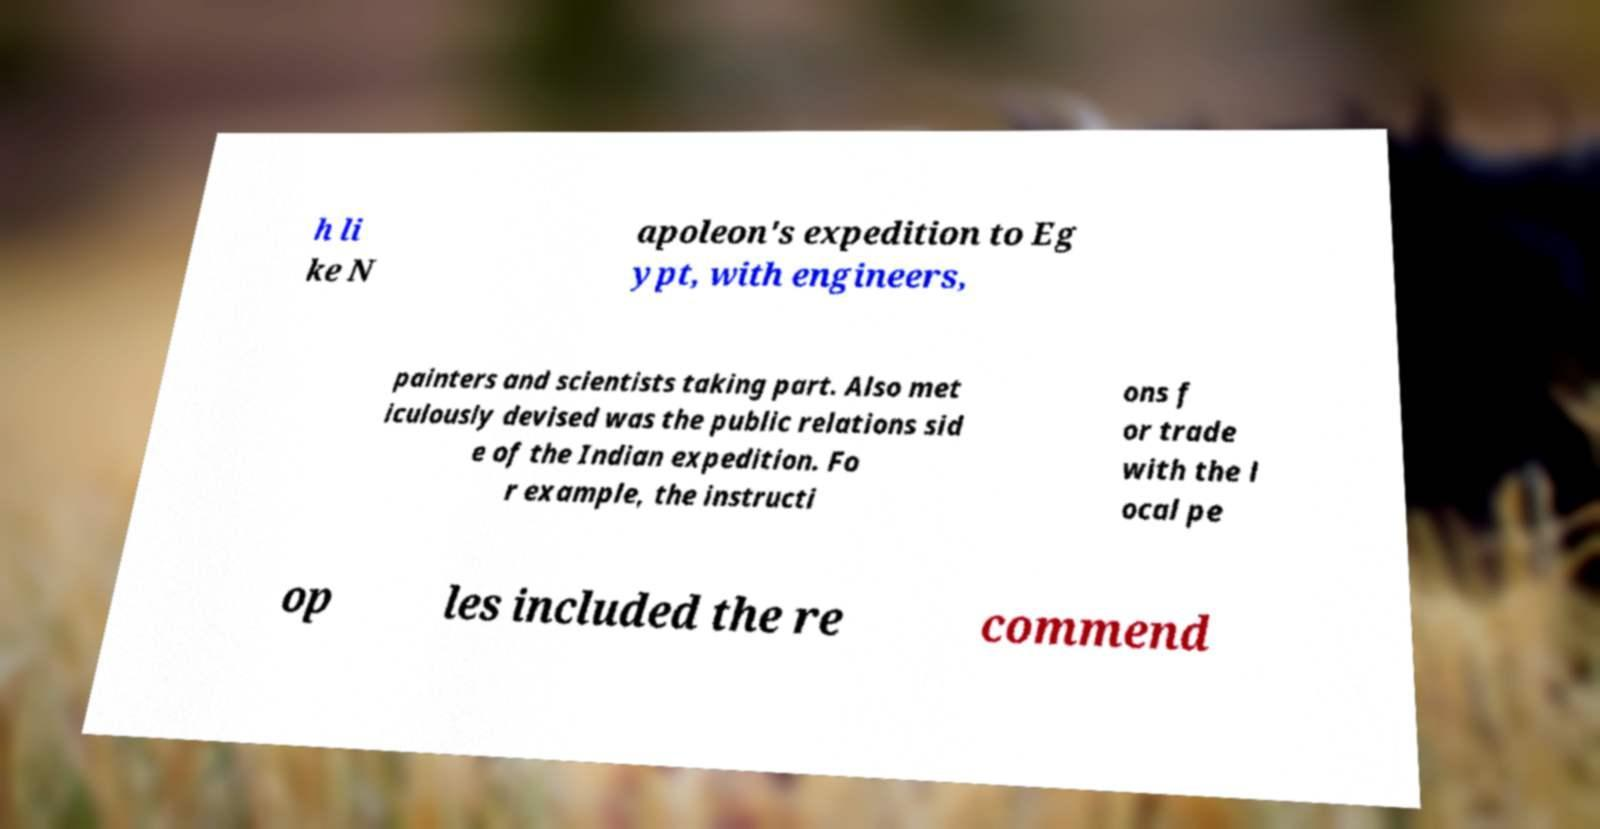Can you accurately transcribe the text from the provided image for me? h li ke N apoleon's expedition to Eg ypt, with engineers, painters and scientists taking part. Also met iculously devised was the public relations sid e of the Indian expedition. Fo r example, the instructi ons f or trade with the l ocal pe op les included the re commend 